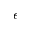<formula> <loc_0><loc_0><loc_500><loc_500>\epsilon</formula> 